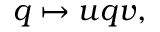Convert formula to latex. <formula><loc_0><loc_0><loc_500><loc_500>q \mapsto u q v ,</formula> 